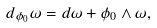Convert formula to latex. <formula><loc_0><loc_0><loc_500><loc_500>d _ { \phi _ { 0 } } \omega = d \omega + \phi _ { 0 } \wedge \omega ,</formula> 